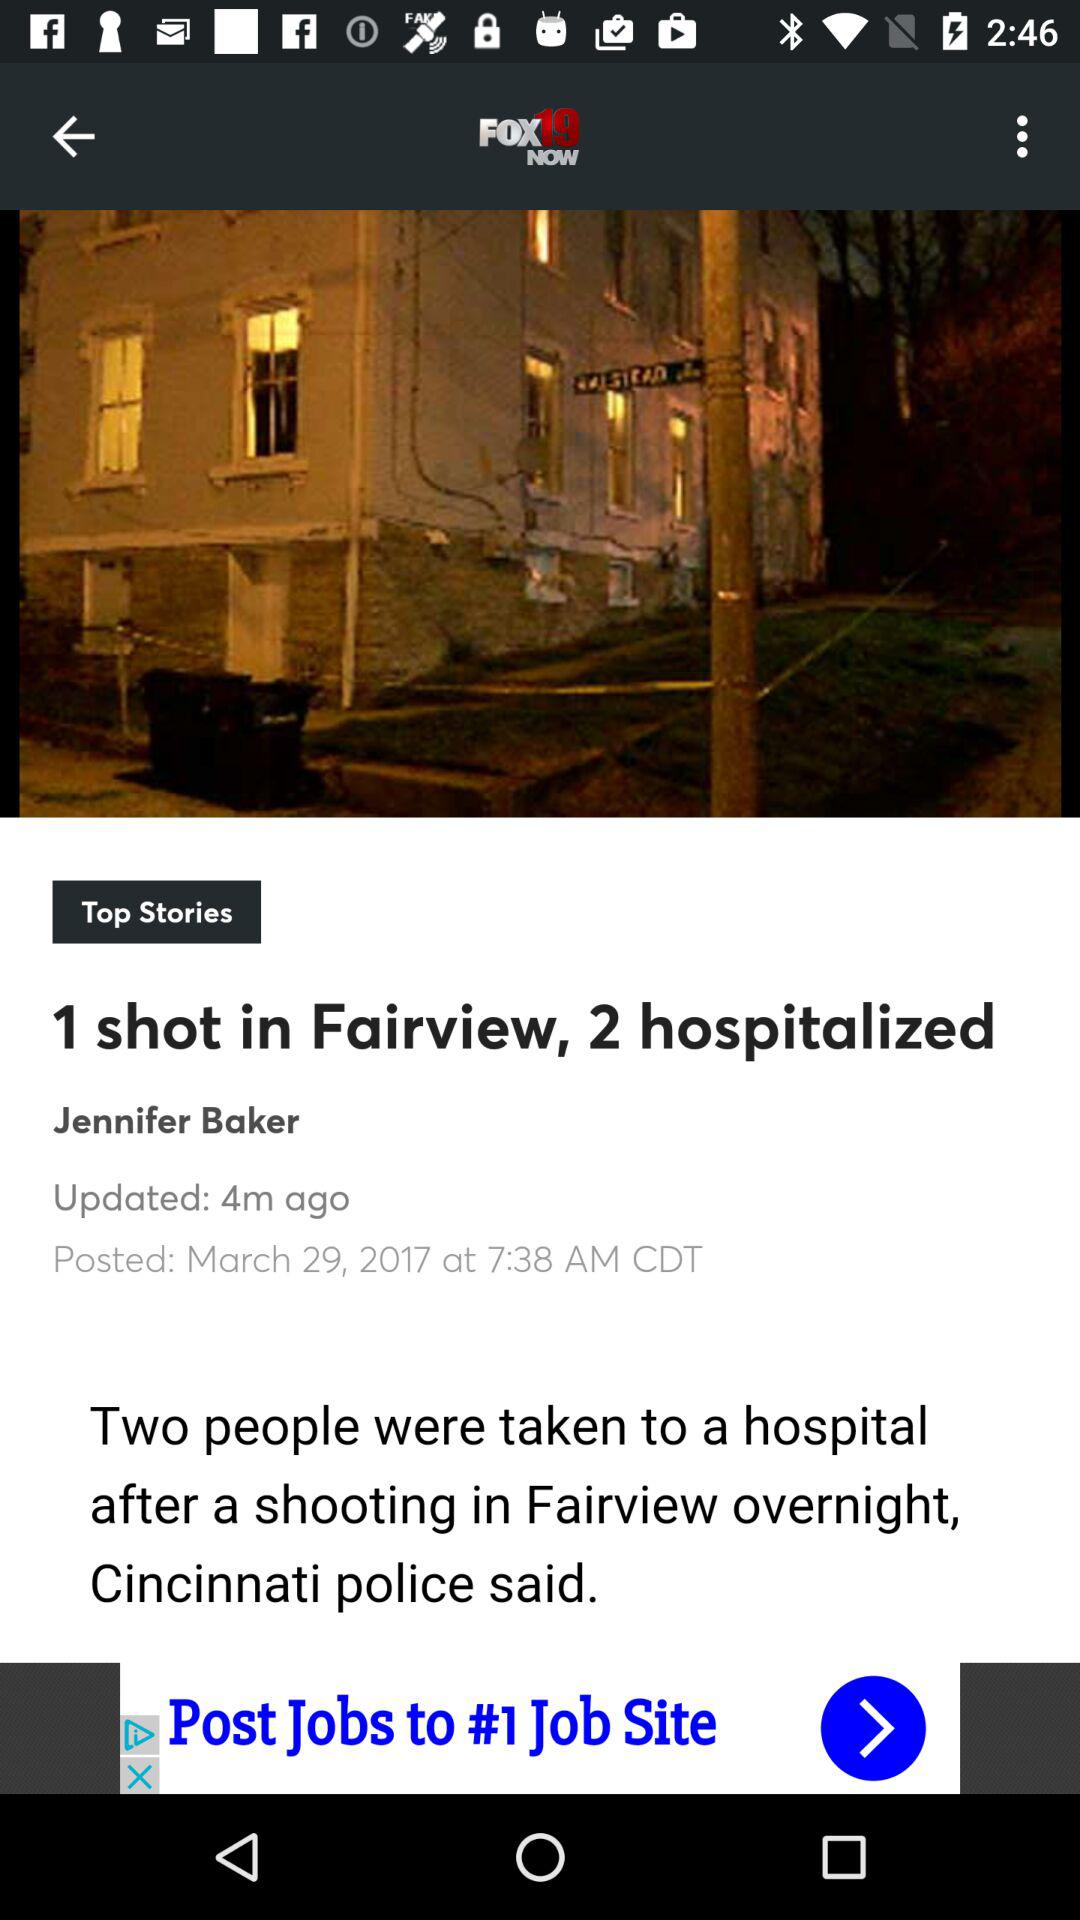When was the news updated? The news was updated 4 minutes ago. 